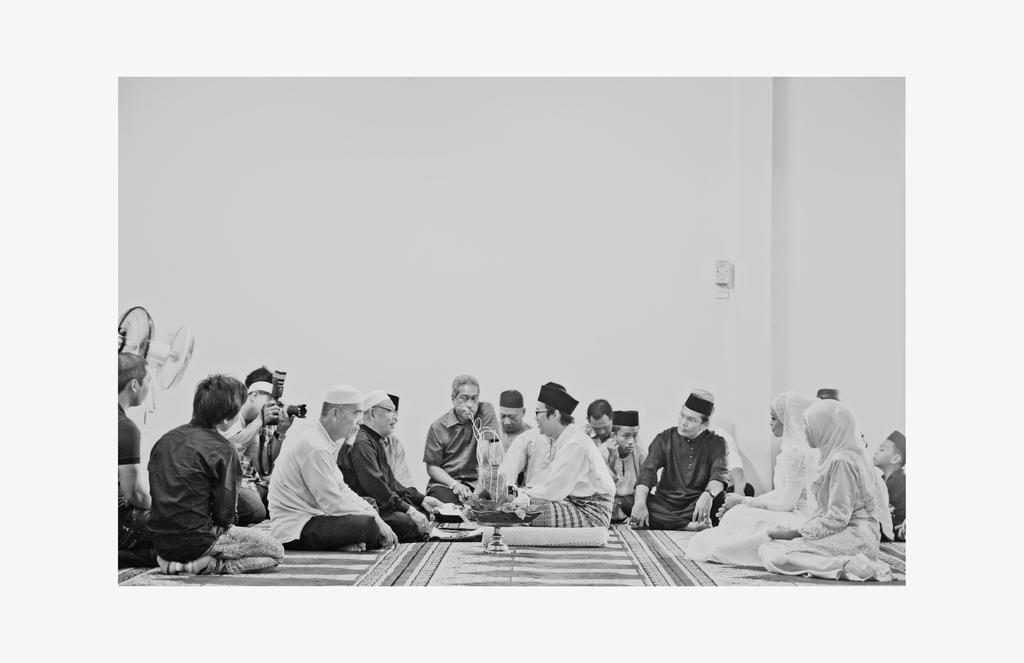How would you summarize this image in a sentence or two? This image is a black and white image. This image is an edited image. In the background there is a wall and there is a table fan. In the middle of the image a few people are sitting on the floor. There is an object on the floor and a person is holding a camera in his hands and clicking pictures. At the bottom of the image there is a mat on the floor. 